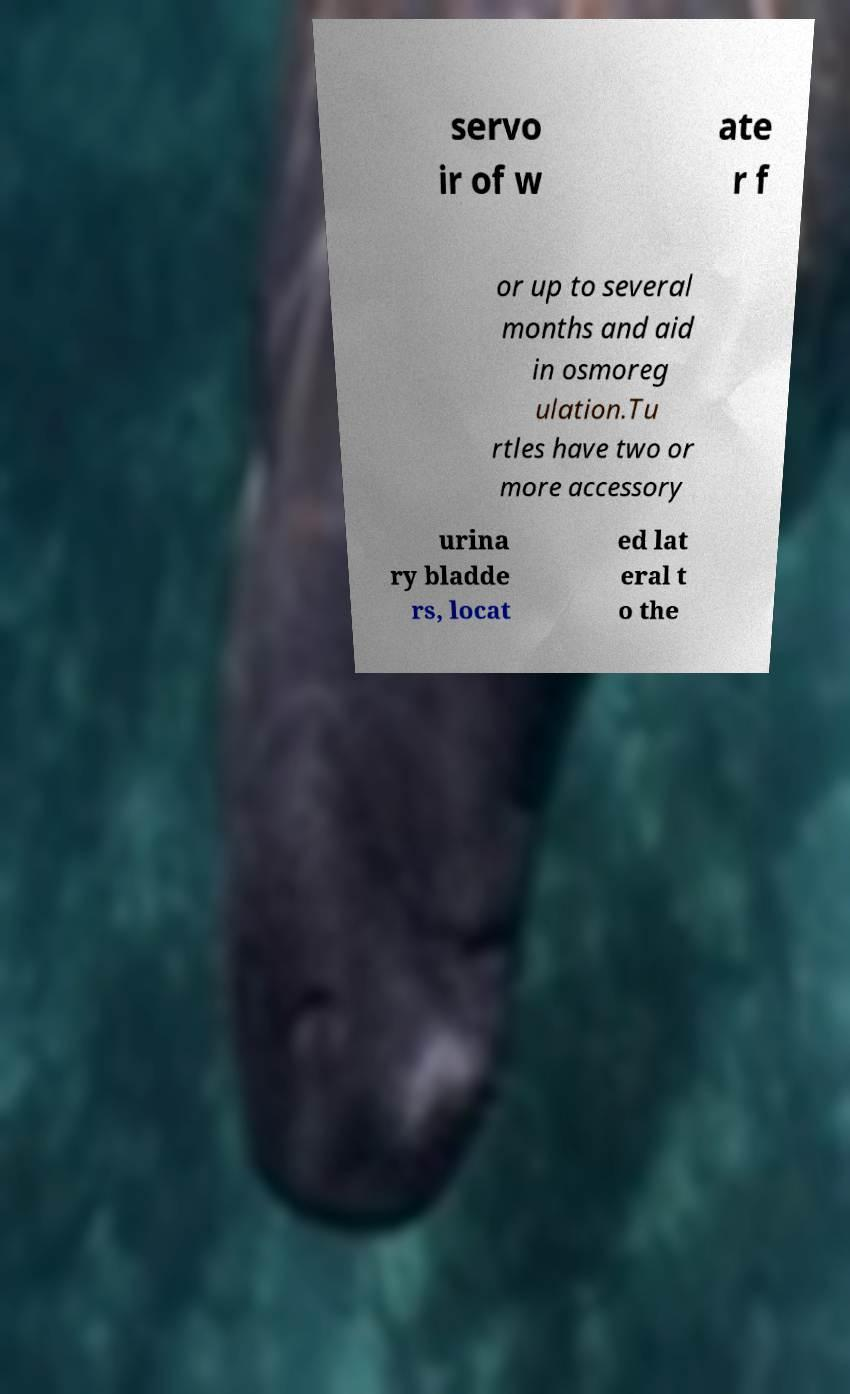There's text embedded in this image that I need extracted. Can you transcribe it verbatim? servo ir of w ate r f or up to several months and aid in osmoreg ulation.Tu rtles have two or more accessory urina ry bladde rs, locat ed lat eral t o the 